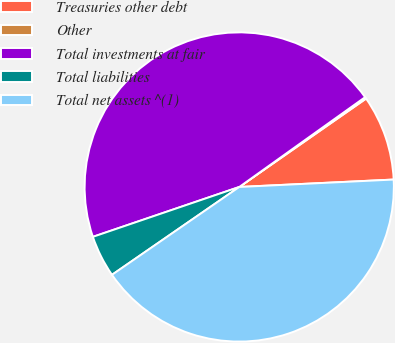<chart> <loc_0><loc_0><loc_500><loc_500><pie_chart><fcel>Treasuries other debt<fcel>Other<fcel>Total investments at fair<fcel>Total liabilities<fcel>Total net assets ^(1)<nl><fcel>8.92%<fcel>0.18%<fcel>45.36%<fcel>4.39%<fcel>41.15%<nl></chart> 